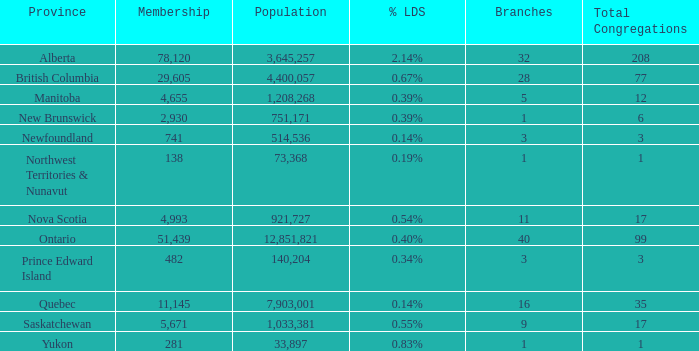What's the sum of population when the membership is 51,439 for fewer than 40 branches? None. 